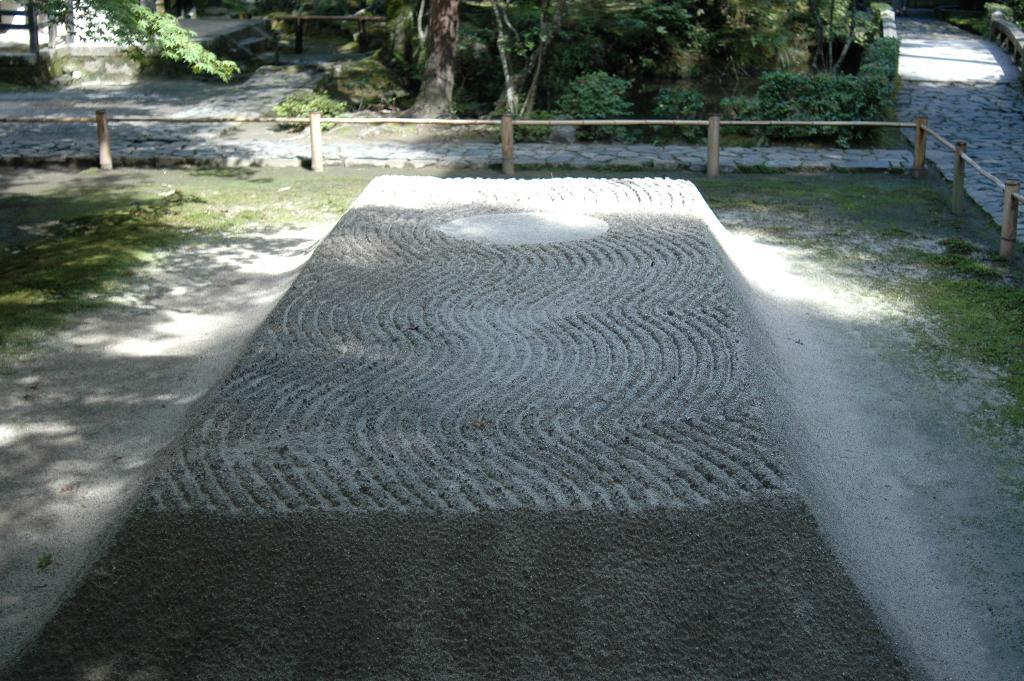What is the main structure in the foreground of the image? There is a concrete stage in the foreground of the image. What can be seen in the background of the image? There is a group of wood poles, a group of trees, a staircase, and a bridge in the background of the image. What type of coat is the class wearing in the image? There is no class or coat present in the image. Is the plastic visible in the image? There is no plastic visible in the image. 